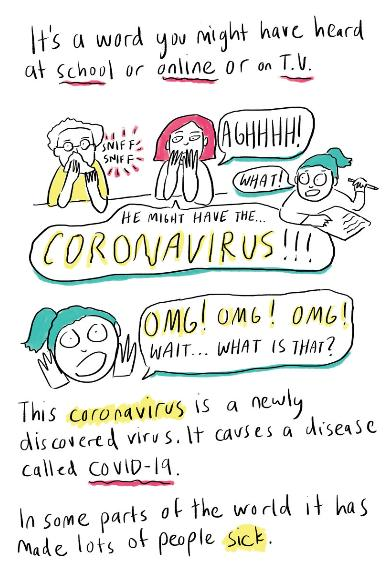Outline some significant characteristics in this image. Covid-19, also known as the coronavirus, is the infectious agent that causes the disease. The classification of coronavirus as either a bacteria, fungi, or virus has been determined to be a virus. It is primarily through school, online sources, and television that children learn about the COVID-19 pandemic. 